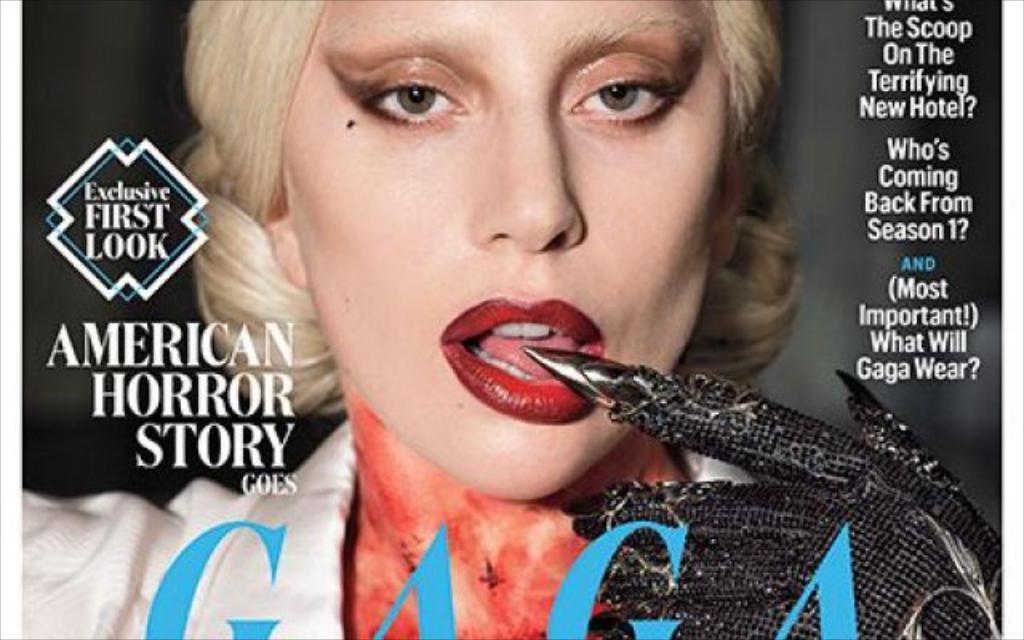Describe this image in one or two sentences. This looks like a poster. I can see a woman with the white dress and a hand glove, which is black in color. These are the letters on the poster. 